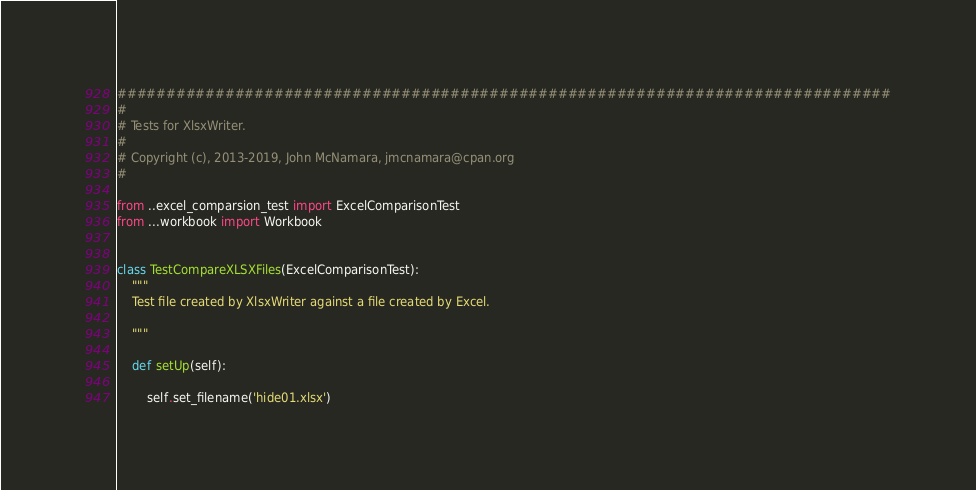<code> <loc_0><loc_0><loc_500><loc_500><_Python_>###############################################################################
#
# Tests for XlsxWriter.
#
# Copyright (c), 2013-2019, John McNamara, jmcnamara@cpan.org
#

from ..excel_comparsion_test import ExcelComparisonTest
from ...workbook import Workbook


class TestCompareXLSXFiles(ExcelComparisonTest):
    """
    Test file created by XlsxWriter against a file created by Excel.

    """

    def setUp(self):

        self.set_filename('hide01.xlsx')
</code> 